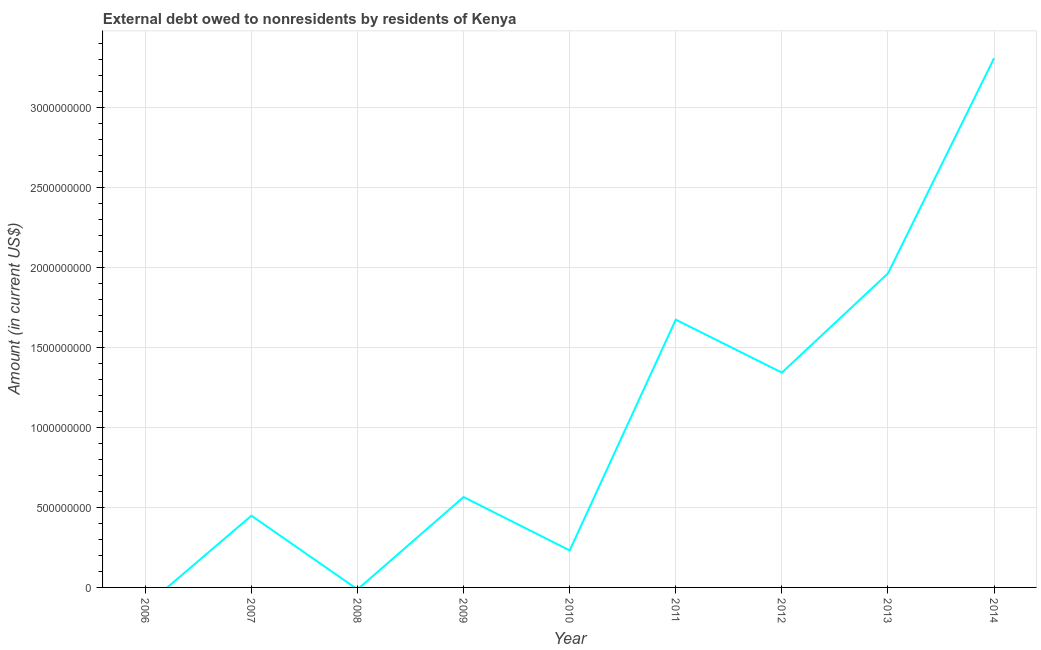What is the debt in 2012?
Ensure brevity in your answer.  1.34e+09. Across all years, what is the maximum debt?
Your answer should be very brief. 3.31e+09. Across all years, what is the minimum debt?
Make the answer very short. 0. In which year was the debt maximum?
Give a very brief answer. 2014. What is the sum of the debt?
Offer a terse response. 9.53e+09. What is the difference between the debt in 2007 and 2010?
Make the answer very short. 2.17e+08. What is the average debt per year?
Your response must be concise. 1.06e+09. What is the median debt?
Give a very brief answer. 5.65e+08. In how many years, is the debt greater than 900000000 US$?
Keep it short and to the point. 4. What is the ratio of the debt in 2012 to that in 2013?
Make the answer very short. 0.68. Is the debt in 2013 less than that in 2014?
Keep it short and to the point. Yes. What is the difference between the highest and the second highest debt?
Offer a terse response. 1.34e+09. What is the difference between the highest and the lowest debt?
Provide a short and direct response. 3.31e+09. In how many years, is the debt greater than the average debt taken over all years?
Your answer should be very brief. 4. How many lines are there?
Your response must be concise. 1. How many years are there in the graph?
Keep it short and to the point. 9. What is the difference between two consecutive major ticks on the Y-axis?
Make the answer very short. 5.00e+08. Does the graph contain any zero values?
Ensure brevity in your answer.  Yes. Does the graph contain grids?
Offer a very short reply. Yes. What is the title of the graph?
Ensure brevity in your answer.  External debt owed to nonresidents by residents of Kenya. What is the label or title of the X-axis?
Ensure brevity in your answer.  Year. What is the label or title of the Y-axis?
Make the answer very short. Amount (in current US$). What is the Amount (in current US$) in 2006?
Provide a succinct answer. 0. What is the Amount (in current US$) in 2007?
Your response must be concise. 4.48e+08. What is the Amount (in current US$) in 2009?
Your response must be concise. 5.65e+08. What is the Amount (in current US$) of 2010?
Offer a very short reply. 2.31e+08. What is the Amount (in current US$) of 2011?
Offer a very short reply. 1.67e+09. What is the Amount (in current US$) of 2012?
Your response must be concise. 1.34e+09. What is the Amount (in current US$) of 2013?
Your response must be concise. 1.96e+09. What is the Amount (in current US$) in 2014?
Provide a succinct answer. 3.31e+09. What is the difference between the Amount (in current US$) in 2007 and 2009?
Keep it short and to the point. -1.17e+08. What is the difference between the Amount (in current US$) in 2007 and 2010?
Offer a very short reply. 2.17e+08. What is the difference between the Amount (in current US$) in 2007 and 2011?
Offer a terse response. -1.23e+09. What is the difference between the Amount (in current US$) in 2007 and 2012?
Make the answer very short. -8.94e+08. What is the difference between the Amount (in current US$) in 2007 and 2013?
Offer a terse response. -1.51e+09. What is the difference between the Amount (in current US$) in 2007 and 2014?
Make the answer very short. -2.86e+09. What is the difference between the Amount (in current US$) in 2009 and 2010?
Give a very brief answer. 3.34e+08. What is the difference between the Amount (in current US$) in 2009 and 2011?
Provide a short and direct response. -1.11e+09. What is the difference between the Amount (in current US$) in 2009 and 2012?
Give a very brief answer. -7.78e+08. What is the difference between the Amount (in current US$) in 2009 and 2013?
Your answer should be compact. -1.40e+09. What is the difference between the Amount (in current US$) in 2009 and 2014?
Provide a succinct answer. -2.74e+09. What is the difference between the Amount (in current US$) in 2010 and 2011?
Give a very brief answer. -1.44e+09. What is the difference between the Amount (in current US$) in 2010 and 2012?
Provide a short and direct response. -1.11e+09. What is the difference between the Amount (in current US$) in 2010 and 2013?
Give a very brief answer. -1.73e+09. What is the difference between the Amount (in current US$) in 2010 and 2014?
Provide a short and direct response. -3.08e+09. What is the difference between the Amount (in current US$) in 2011 and 2012?
Your answer should be very brief. 3.31e+08. What is the difference between the Amount (in current US$) in 2011 and 2013?
Ensure brevity in your answer.  -2.89e+08. What is the difference between the Amount (in current US$) in 2011 and 2014?
Ensure brevity in your answer.  -1.63e+09. What is the difference between the Amount (in current US$) in 2012 and 2013?
Ensure brevity in your answer.  -6.20e+08. What is the difference between the Amount (in current US$) in 2012 and 2014?
Your answer should be compact. -1.97e+09. What is the difference between the Amount (in current US$) in 2013 and 2014?
Offer a terse response. -1.34e+09. What is the ratio of the Amount (in current US$) in 2007 to that in 2009?
Keep it short and to the point. 0.79. What is the ratio of the Amount (in current US$) in 2007 to that in 2010?
Your answer should be very brief. 1.94. What is the ratio of the Amount (in current US$) in 2007 to that in 2011?
Keep it short and to the point. 0.27. What is the ratio of the Amount (in current US$) in 2007 to that in 2012?
Give a very brief answer. 0.33. What is the ratio of the Amount (in current US$) in 2007 to that in 2013?
Keep it short and to the point. 0.23. What is the ratio of the Amount (in current US$) in 2007 to that in 2014?
Ensure brevity in your answer.  0.14. What is the ratio of the Amount (in current US$) in 2009 to that in 2010?
Make the answer very short. 2.44. What is the ratio of the Amount (in current US$) in 2009 to that in 2011?
Your answer should be very brief. 0.34. What is the ratio of the Amount (in current US$) in 2009 to that in 2012?
Provide a succinct answer. 0.42. What is the ratio of the Amount (in current US$) in 2009 to that in 2013?
Make the answer very short. 0.29. What is the ratio of the Amount (in current US$) in 2009 to that in 2014?
Offer a terse response. 0.17. What is the ratio of the Amount (in current US$) in 2010 to that in 2011?
Your answer should be compact. 0.14. What is the ratio of the Amount (in current US$) in 2010 to that in 2012?
Provide a short and direct response. 0.17. What is the ratio of the Amount (in current US$) in 2010 to that in 2013?
Give a very brief answer. 0.12. What is the ratio of the Amount (in current US$) in 2010 to that in 2014?
Give a very brief answer. 0.07. What is the ratio of the Amount (in current US$) in 2011 to that in 2012?
Offer a very short reply. 1.25. What is the ratio of the Amount (in current US$) in 2011 to that in 2013?
Ensure brevity in your answer.  0.85. What is the ratio of the Amount (in current US$) in 2011 to that in 2014?
Keep it short and to the point. 0.51. What is the ratio of the Amount (in current US$) in 2012 to that in 2013?
Make the answer very short. 0.68. What is the ratio of the Amount (in current US$) in 2012 to that in 2014?
Ensure brevity in your answer.  0.41. What is the ratio of the Amount (in current US$) in 2013 to that in 2014?
Your answer should be very brief. 0.59. 